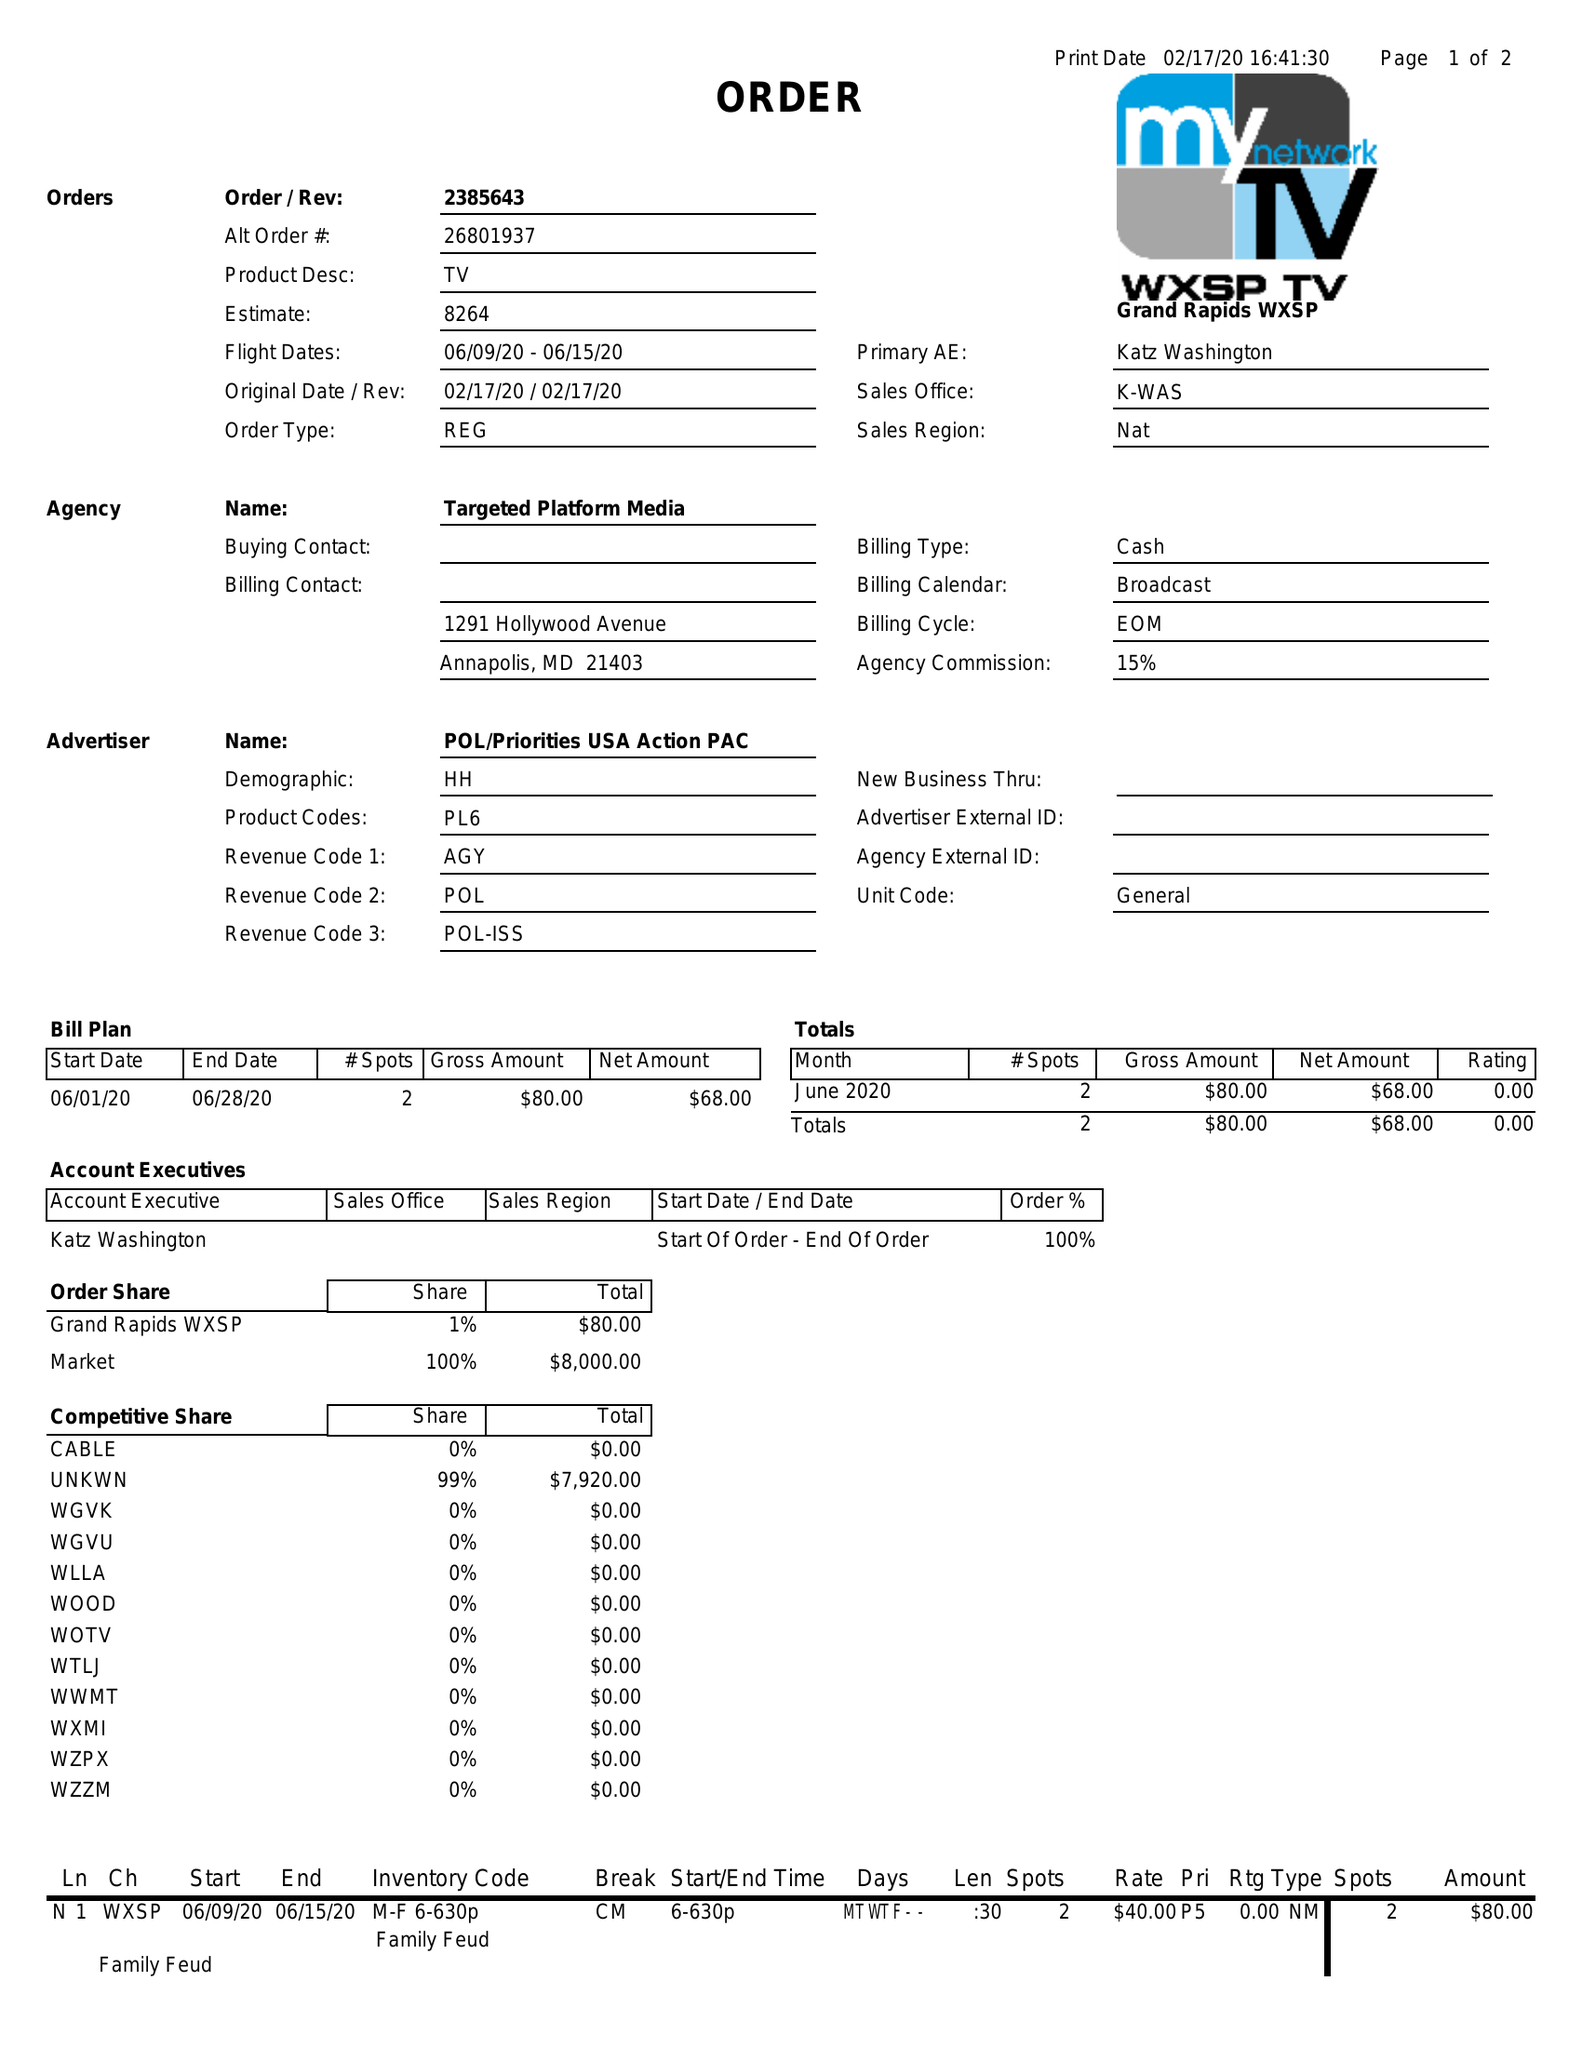What is the value for the advertiser?
Answer the question using a single word or phrase. POL/PRIORITIESUSAACTIONPAC 